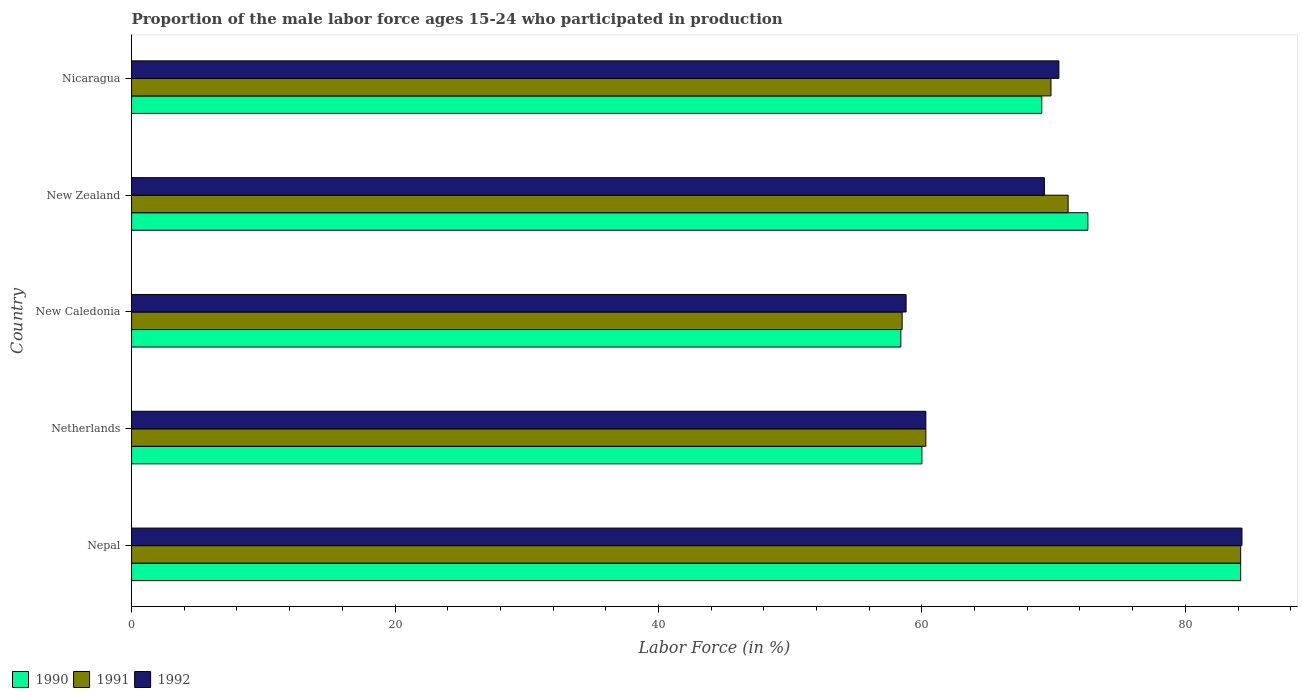How many different coloured bars are there?
Your response must be concise. 3. Are the number of bars on each tick of the Y-axis equal?
Make the answer very short. Yes. What is the label of the 5th group of bars from the top?
Give a very brief answer. Nepal. In how many cases, is the number of bars for a given country not equal to the number of legend labels?
Make the answer very short. 0. What is the proportion of the male labor force who participated in production in 1990 in Nepal?
Provide a short and direct response. 84.2. Across all countries, what is the maximum proportion of the male labor force who participated in production in 1990?
Your response must be concise. 84.2. Across all countries, what is the minimum proportion of the male labor force who participated in production in 1992?
Provide a succinct answer. 58.8. In which country was the proportion of the male labor force who participated in production in 1991 maximum?
Offer a terse response. Nepal. In which country was the proportion of the male labor force who participated in production in 1992 minimum?
Your answer should be compact. New Caledonia. What is the total proportion of the male labor force who participated in production in 1990 in the graph?
Provide a succinct answer. 344.3. What is the difference between the proportion of the male labor force who participated in production in 1991 in Nepal and that in New Zealand?
Offer a terse response. 13.1. What is the difference between the proportion of the male labor force who participated in production in 1990 in New Zealand and the proportion of the male labor force who participated in production in 1991 in Nicaragua?
Make the answer very short. 2.8. What is the average proportion of the male labor force who participated in production in 1992 per country?
Keep it short and to the point. 68.62. What is the difference between the proportion of the male labor force who participated in production in 1990 and proportion of the male labor force who participated in production in 1991 in Netherlands?
Ensure brevity in your answer.  -0.3. In how many countries, is the proportion of the male labor force who participated in production in 1992 greater than 16 %?
Your answer should be very brief. 5. What is the ratio of the proportion of the male labor force who participated in production in 1992 in New Caledonia to that in Nicaragua?
Your response must be concise. 0.84. Is the proportion of the male labor force who participated in production in 1992 in Netherlands less than that in Nicaragua?
Your response must be concise. Yes. What is the difference between the highest and the second highest proportion of the male labor force who participated in production in 1990?
Your answer should be compact. 11.6. What is the difference between the highest and the lowest proportion of the male labor force who participated in production in 1990?
Provide a succinct answer. 25.8. What does the 1st bar from the top in Nicaragua represents?
Make the answer very short. 1992. What does the 1st bar from the bottom in New Zealand represents?
Ensure brevity in your answer.  1990. Is it the case that in every country, the sum of the proportion of the male labor force who participated in production in 1991 and proportion of the male labor force who participated in production in 1992 is greater than the proportion of the male labor force who participated in production in 1990?
Your answer should be compact. Yes. Are all the bars in the graph horizontal?
Your answer should be compact. Yes. Are the values on the major ticks of X-axis written in scientific E-notation?
Make the answer very short. No. Does the graph contain any zero values?
Keep it short and to the point. No. What is the title of the graph?
Provide a succinct answer. Proportion of the male labor force ages 15-24 who participated in production. Does "1989" appear as one of the legend labels in the graph?
Make the answer very short. No. What is the label or title of the X-axis?
Your response must be concise. Labor Force (in %). What is the Labor Force (in %) in 1990 in Nepal?
Provide a short and direct response. 84.2. What is the Labor Force (in %) in 1991 in Nepal?
Offer a terse response. 84.2. What is the Labor Force (in %) in 1992 in Nepal?
Offer a very short reply. 84.3. What is the Labor Force (in %) of 1991 in Netherlands?
Your response must be concise. 60.3. What is the Labor Force (in %) in 1992 in Netherlands?
Your answer should be compact. 60.3. What is the Labor Force (in %) of 1990 in New Caledonia?
Your response must be concise. 58.4. What is the Labor Force (in %) in 1991 in New Caledonia?
Your answer should be compact. 58.5. What is the Labor Force (in %) in 1992 in New Caledonia?
Keep it short and to the point. 58.8. What is the Labor Force (in %) in 1990 in New Zealand?
Give a very brief answer. 72.6. What is the Labor Force (in %) in 1991 in New Zealand?
Your answer should be very brief. 71.1. What is the Labor Force (in %) in 1992 in New Zealand?
Keep it short and to the point. 69.3. What is the Labor Force (in %) in 1990 in Nicaragua?
Offer a very short reply. 69.1. What is the Labor Force (in %) of 1991 in Nicaragua?
Ensure brevity in your answer.  69.8. What is the Labor Force (in %) of 1992 in Nicaragua?
Offer a terse response. 70.4. Across all countries, what is the maximum Labor Force (in %) of 1990?
Keep it short and to the point. 84.2. Across all countries, what is the maximum Labor Force (in %) of 1991?
Make the answer very short. 84.2. Across all countries, what is the maximum Labor Force (in %) of 1992?
Your answer should be very brief. 84.3. Across all countries, what is the minimum Labor Force (in %) in 1990?
Make the answer very short. 58.4. Across all countries, what is the minimum Labor Force (in %) in 1991?
Ensure brevity in your answer.  58.5. Across all countries, what is the minimum Labor Force (in %) in 1992?
Provide a succinct answer. 58.8. What is the total Labor Force (in %) in 1990 in the graph?
Keep it short and to the point. 344.3. What is the total Labor Force (in %) in 1991 in the graph?
Your response must be concise. 343.9. What is the total Labor Force (in %) of 1992 in the graph?
Give a very brief answer. 343.1. What is the difference between the Labor Force (in %) in 1990 in Nepal and that in Netherlands?
Your response must be concise. 24.2. What is the difference between the Labor Force (in %) in 1991 in Nepal and that in Netherlands?
Give a very brief answer. 23.9. What is the difference between the Labor Force (in %) in 1990 in Nepal and that in New Caledonia?
Keep it short and to the point. 25.8. What is the difference between the Labor Force (in %) in 1991 in Nepal and that in New Caledonia?
Give a very brief answer. 25.7. What is the difference between the Labor Force (in %) of 1990 in Nepal and that in Nicaragua?
Give a very brief answer. 15.1. What is the difference between the Labor Force (in %) of 1991 in Nepal and that in Nicaragua?
Keep it short and to the point. 14.4. What is the difference between the Labor Force (in %) in 1992 in Netherlands and that in New Caledonia?
Keep it short and to the point. 1.5. What is the difference between the Labor Force (in %) of 1990 in Netherlands and that in New Zealand?
Keep it short and to the point. -12.6. What is the difference between the Labor Force (in %) in 1990 in Netherlands and that in Nicaragua?
Keep it short and to the point. -9.1. What is the difference between the Labor Force (in %) in 1991 in Netherlands and that in Nicaragua?
Your answer should be very brief. -9.5. What is the difference between the Labor Force (in %) in 1991 in New Zealand and that in Nicaragua?
Give a very brief answer. 1.3. What is the difference between the Labor Force (in %) in 1990 in Nepal and the Labor Force (in %) in 1991 in Netherlands?
Provide a short and direct response. 23.9. What is the difference between the Labor Force (in %) of 1990 in Nepal and the Labor Force (in %) of 1992 in Netherlands?
Keep it short and to the point. 23.9. What is the difference between the Labor Force (in %) in 1991 in Nepal and the Labor Force (in %) in 1992 in Netherlands?
Your response must be concise. 23.9. What is the difference between the Labor Force (in %) in 1990 in Nepal and the Labor Force (in %) in 1991 in New Caledonia?
Your answer should be compact. 25.7. What is the difference between the Labor Force (in %) in 1990 in Nepal and the Labor Force (in %) in 1992 in New Caledonia?
Offer a terse response. 25.4. What is the difference between the Labor Force (in %) in 1991 in Nepal and the Labor Force (in %) in 1992 in New Caledonia?
Provide a short and direct response. 25.4. What is the difference between the Labor Force (in %) of 1990 in Nepal and the Labor Force (in %) of 1991 in New Zealand?
Provide a short and direct response. 13.1. What is the difference between the Labor Force (in %) in 1990 in Nepal and the Labor Force (in %) in 1992 in New Zealand?
Provide a succinct answer. 14.9. What is the difference between the Labor Force (in %) in 1991 in Nepal and the Labor Force (in %) in 1992 in New Zealand?
Your response must be concise. 14.9. What is the difference between the Labor Force (in %) of 1990 in Netherlands and the Labor Force (in %) of 1991 in New Caledonia?
Your answer should be very brief. 1.5. What is the difference between the Labor Force (in %) in 1990 in Netherlands and the Labor Force (in %) in 1991 in Nicaragua?
Keep it short and to the point. -9.8. What is the difference between the Labor Force (in %) of 1990 in Netherlands and the Labor Force (in %) of 1992 in Nicaragua?
Your response must be concise. -10.4. What is the difference between the Labor Force (in %) of 1990 in New Caledonia and the Labor Force (in %) of 1992 in New Zealand?
Keep it short and to the point. -10.9. What is the difference between the Labor Force (in %) of 1991 in New Caledonia and the Labor Force (in %) of 1992 in New Zealand?
Provide a short and direct response. -10.8. What is the difference between the Labor Force (in %) in 1990 in New Caledonia and the Labor Force (in %) in 1991 in Nicaragua?
Give a very brief answer. -11.4. What is the difference between the Labor Force (in %) of 1991 in New Caledonia and the Labor Force (in %) of 1992 in Nicaragua?
Ensure brevity in your answer.  -11.9. What is the difference between the Labor Force (in %) of 1990 in New Zealand and the Labor Force (in %) of 1992 in Nicaragua?
Keep it short and to the point. 2.2. What is the average Labor Force (in %) of 1990 per country?
Your answer should be very brief. 68.86. What is the average Labor Force (in %) of 1991 per country?
Provide a succinct answer. 68.78. What is the average Labor Force (in %) in 1992 per country?
Make the answer very short. 68.62. What is the difference between the Labor Force (in %) of 1990 and Labor Force (in %) of 1991 in Nepal?
Offer a very short reply. 0. What is the difference between the Labor Force (in %) in 1991 and Labor Force (in %) in 1992 in Nepal?
Make the answer very short. -0.1. What is the difference between the Labor Force (in %) in 1990 and Labor Force (in %) in 1991 in Netherlands?
Your answer should be very brief. -0.3. What is the difference between the Labor Force (in %) of 1990 and Labor Force (in %) of 1992 in Netherlands?
Keep it short and to the point. -0.3. What is the difference between the Labor Force (in %) of 1990 and Labor Force (in %) of 1992 in New Caledonia?
Keep it short and to the point. -0.4. What is the difference between the Labor Force (in %) of 1990 and Labor Force (in %) of 1991 in New Zealand?
Provide a short and direct response. 1.5. What is the difference between the Labor Force (in %) of 1990 and Labor Force (in %) of 1991 in Nicaragua?
Give a very brief answer. -0.7. What is the difference between the Labor Force (in %) of 1991 and Labor Force (in %) of 1992 in Nicaragua?
Ensure brevity in your answer.  -0.6. What is the ratio of the Labor Force (in %) of 1990 in Nepal to that in Netherlands?
Your answer should be very brief. 1.4. What is the ratio of the Labor Force (in %) in 1991 in Nepal to that in Netherlands?
Your response must be concise. 1.4. What is the ratio of the Labor Force (in %) in 1992 in Nepal to that in Netherlands?
Your answer should be very brief. 1.4. What is the ratio of the Labor Force (in %) in 1990 in Nepal to that in New Caledonia?
Your response must be concise. 1.44. What is the ratio of the Labor Force (in %) in 1991 in Nepal to that in New Caledonia?
Make the answer very short. 1.44. What is the ratio of the Labor Force (in %) in 1992 in Nepal to that in New Caledonia?
Give a very brief answer. 1.43. What is the ratio of the Labor Force (in %) of 1990 in Nepal to that in New Zealand?
Offer a very short reply. 1.16. What is the ratio of the Labor Force (in %) in 1991 in Nepal to that in New Zealand?
Keep it short and to the point. 1.18. What is the ratio of the Labor Force (in %) of 1992 in Nepal to that in New Zealand?
Your answer should be very brief. 1.22. What is the ratio of the Labor Force (in %) of 1990 in Nepal to that in Nicaragua?
Give a very brief answer. 1.22. What is the ratio of the Labor Force (in %) in 1991 in Nepal to that in Nicaragua?
Provide a succinct answer. 1.21. What is the ratio of the Labor Force (in %) in 1992 in Nepal to that in Nicaragua?
Ensure brevity in your answer.  1.2. What is the ratio of the Labor Force (in %) in 1990 in Netherlands to that in New Caledonia?
Your response must be concise. 1.03. What is the ratio of the Labor Force (in %) in 1991 in Netherlands to that in New Caledonia?
Make the answer very short. 1.03. What is the ratio of the Labor Force (in %) in 1992 in Netherlands to that in New Caledonia?
Give a very brief answer. 1.03. What is the ratio of the Labor Force (in %) of 1990 in Netherlands to that in New Zealand?
Your answer should be very brief. 0.83. What is the ratio of the Labor Force (in %) of 1991 in Netherlands to that in New Zealand?
Your answer should be very brief. 0.85. What is the ratio of the Labor Force (in %) in 1992 in Netherlands to that in New Zealand?
Provide a short and direct response. 0.87. What is the ratio of the Labor Force (in %) of 1990 in Netherlands to that in Nicaragua?
Keep it short and to the point. 0.87. What is the ratio of the Labor Force (in %) of 1991 in Netherlands to that in Nicaragua?
Ensure brevity in your answer.  0.86. What is the ratio of the Labor Force (in %) in 1992 in Netherlands to that in Nicaragua?
Give a very brief answer. 0.86. What is the ratio of the Labor Force (in %) in 1990 in New Caledonia to that in New Zealand?
Your response must be concise. 0.8. What is the ratio of the Labor Force (in %) of 1991 in New Caledonia to that in New Zealand?
Your answer should be very brief. 0.82. What is the ratio of the Labor Force (in %) of 1992 in New Caledonia to that in New Zealand?
Make the answer very short. 0.85. What is the ratio of the Labor Force (in %) of 1990 in New Caledonia to that in Nicaragua?
Make the answer very short. 0.85. What is the ratio of the Labor Force (in %) in 1991 in New Caledonia to that in Nicaragua?
Your answer should be very brief. 0.84. What is the ratio of the Labor Force (in %) in 1992 in New Caledonia to that in Nicaragua?
Make the answer very short. 0.84. What is the ratio of the Labor Force (in %) in 1990 in New Zealand to that in Nicaragua?
Your answer should be very brief. 1.05. What is the ratio of the Labor Force (in %) of 1991 in New Zealand to that in Nicaragua?
Offer a very short reply. 1.02. What is the ratio of the Labor Force (in %) of 1992 in New Zealand to that in Nicaragua?
Your answer should be compact. 0.98. What is the difference between the highest and the second highest Labor Force (in %) in 1991?
Your answer should be very brief. 13.1. What is the difference between the highest and the lowest Labor Force (in %) of 1990?
Your response must be concise. 25.8. What is the difference between the highest and the lowest Labor Force (in %) of 1991?
Make the answer very short. 25.7. 